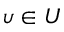<formula> <loc_0><loc_0><loc_500><loc_500>\upsilon \in U</formula> 